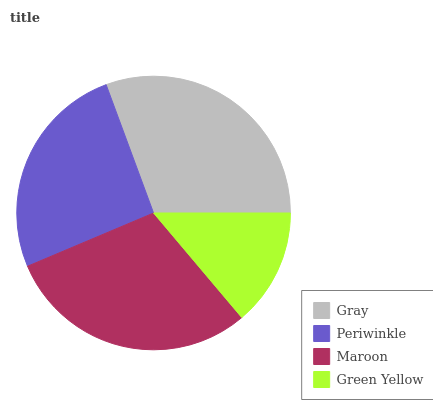Is Green Yellow the minimum?
Answer yes or no. Yes. Is Gray the maximum?
Answer yes or no. Yes. Is Periwinkle the minimum?
Answer yes or no. No. Is Periwinkle the maximum?
Answer yes or no. No. Is Gray greater than Periwinkle?
Answer yes or no. Yes. Is Periwinkle less than Gray?
Answer yes or no. Yes. Is Periwinkle greater than Gray?
Answer yes or no. No. Is Gray less than Periwinkle?
Answer yes or no. No. Is Maroon the high median?
Answer yes or no. Yes. Is Periwinkle the low median?
Answer yes or no. Yes. Is Gray the high median?
Answer yes or no. No. Is Gray the low median?
Answer yes or no. No. 